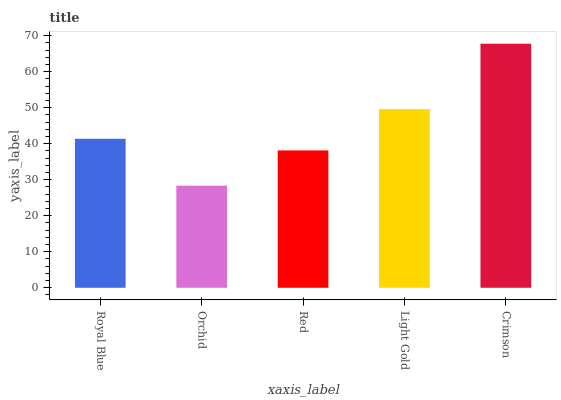Is Orchid the minimum?
Answer yes or no. Yes. Is Crimson the maximum?
Answer yes or no. Yes. Is Red the minimum?
Answer yes or no. No. Is Red the maximum?
Answer yes or no. No. Is Red greater than Orchid?
Answer yes or no. Yes. Is Orchid less than Red?
Answer yes or no. Yes. Is Orchid greater than Red?
Answer yes or no. No. Is Red less than Orchid?
Answer yes or no. No. Is Royal Blue the high median?
Answer yes or no. Yes. Is Royal Blue the low median?
Answer yes or no. Yes. Is Crimson the high median?
Answer yes or no. No. Is Orchid the low median?
Answer yes or no. No. 